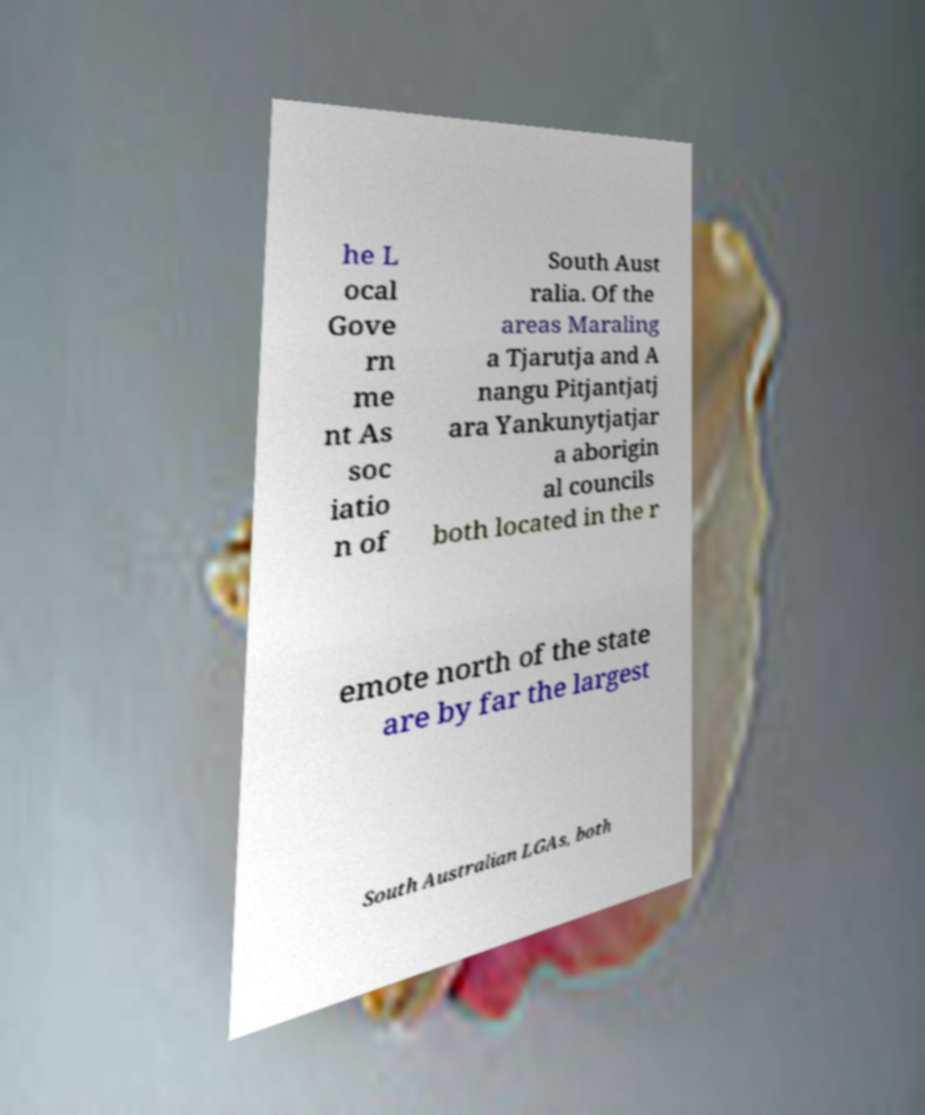Could you extract and type out the text from this image? he L ocal Gove rn me nt As soc iatio n of South Aust ralia. Of the areas Maraling a Tjarutja and A nangu Pitjantjatj ara Yankunytjatjar a aborigin al councils both located in the r emote north of the state are by far the largest South Australian LGAs, both 